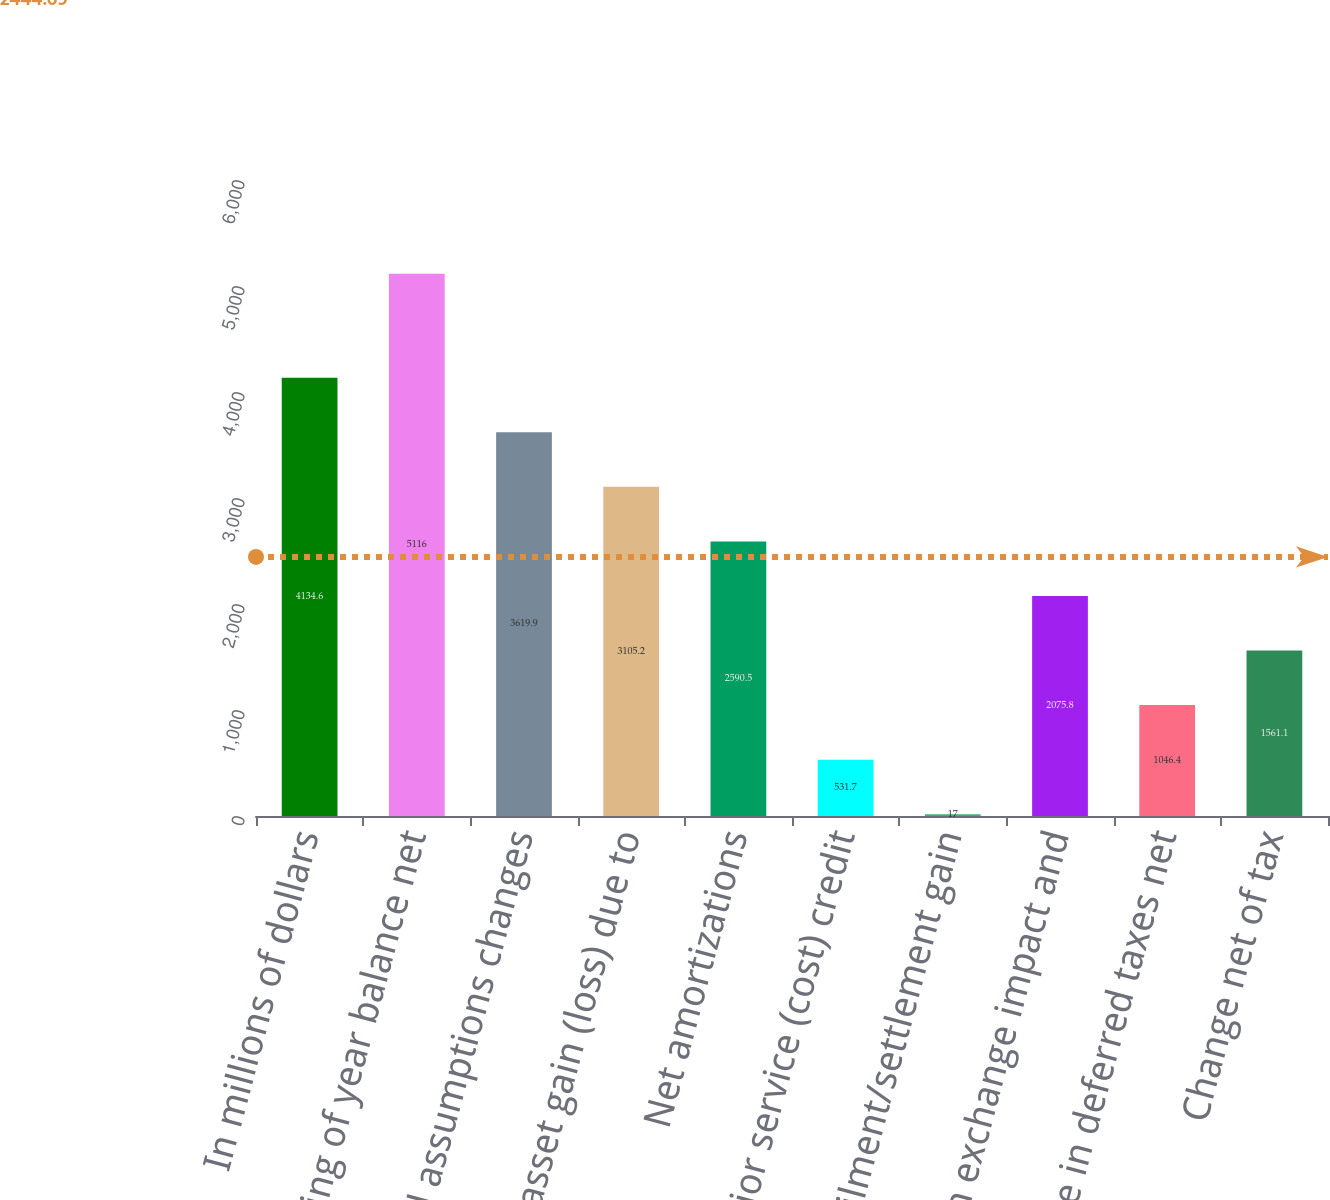Convert chart. <chart><loc_0><loc_0><loc_500><loc_500><bar_chart><fcel>In millions of dollars<fcel>Beginning of year balance net<fcel>Actuarial assumptions changes<fcel>Net asset gain (loss) due to<fcel>Net amortizations<fcel>Prior service (cost) credit<fcel>Curtailment/settlement gain<fcel>Foreign exchange impact and<fcel>Change in deferred taxes net<fcel>Change net of tax<nl><fcel>4134.6<fcel>5116<fcel>3619.9<fcel>3105.2<fcel>2590.5<fcel>531.7<fcel>17<fcel>2075.8<fcel>1046.4<fcel>1561.1<nl></chart> 